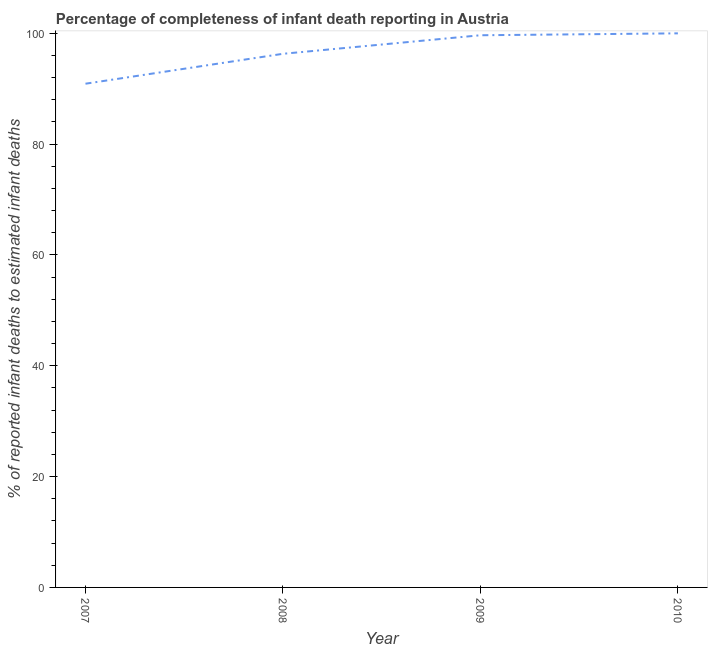What is the completeness of infant death reporting in 2008?
Make the answer very short. 96.31. Across all years, what is the maximum completeness of infant death reporting?
Give a very brief answer. 100. Across all years, what is the minimum completeness of infant death reporting?
Provide a succinct answer. 90.91. In which year was the completeness of infant death reporting maximum?
Your answer should be compact. 2010. What is the sum of the completeness of infant death reporting?
Provide a short and direct response. 386.87. What is the difference between the completeness of infant death reporting in 2008 and 2009?
Keep it short and to the point. -3.35. What is the average completeness of infant death reporting per year?
Your response must be concise. 96.72. What is the median completeness of infant death reporting?
Give a very brief answer. 97.98. In how many years, is the completeness of infant death reporting greater than 88 %?
Offer a terse response. 4. Do a majority of the years between 2010 and 2007 (inclusive) have completeness of infant death reporting greater than 20 %?
Keep it short and to the point. Yes. What is the ratio of the completeness of infant death reporting in 2007 to that in 2010?
Provide a succinct answer. 0.91. Is the completeness of infant death reporting in 2007 less than that in 2009?
Provide a short and direct response. Yes. What is the difference between the highest and the second highest completeness of infant death reporting?
Your answer should be very brief. 0.34. Is the sum of the completeness of infant death reporting in 2009 and 2010 greater than the maximum completeness of infant death reporting across all years?
Make the answer very short. Yes. What is the difference between the highest and the lowest completeness of infant death reporting?
Give a very brief answer. 9.09. In how many years, is the completeness of infant death reporting greater than the average completeness of infant death reporting taken over all years?
Your answer should be very brief. 2. How many lines are there?
Offer a very short reply. 1. Are the values on the major ticks of Y-axis written in scientific E-notation?
Offer a terse response. No. Does the graph contain grids?
Ensure brevity in your answer.  No. What is the title of the graph?
Offer a terse response. Percentage of completeness of infant death reporting in Austria. What is the label or title of the Y-axis?
Ensure brevity in your answer.  % of reported infant deaths to estimated infant deaths. What is the % of reported infant deaths to estimated infant deaths of 2007?
Offer a terse response. 90.91. What is the % of reported infant deaths to estimated infant deaths in 2008?
Offer a terse response. 96.31. What is the % of reported infant deaths to estimated infant deaths in 2009?
Give a very brief answer. 99.66. What is the % of reported infant deaths to estimated infant deaths of 2010?
Your answer should be very brief. 100. What is the difference between the % of reported infant deaths to estimated infant deaths in 2007 and 2008?
Your answer should be compact. -5.4. What is the difference between the % of reported infant deaths to estimated infant deaths in 2007 and 2009?
Offer a terse response. -8.75. What is the difference between the % of reported infant deaths to estimated infant deaths in 2007 and 2010?
Ensure brevity in your answer.  -9.09. What is the difference between the % of reported infant deaths to estimated infant deaths in 2008 and 2009?
Provide a succinct answer. -3.35. What is the difference between the % of reported infant deaths to estimated infant deaths in 2008 and 2010?
Your response must be concise. -3.69. What is the difference between the % of reported infant deaths to estimated infant deaths in 2009 and 2010?
Ensure brevity in your answer.  -0.34. What is the ratio of the % of reported infant deaths to estimated infant deaths in 2007 to that in 2008?
Your answer should be very brief. 0.94. What is the ratio of the % of reported infant deaths to estimated infant deaths in 2007 to that in 2009?
Your answer should be very brief. 0.91. What is the ratio of the % of reported infant deaths to estimated infant deaths in 2007 to that in 2010?
Provide a short and direct response. 0.91. What is the ratio of the % of reported infant deaths to estimated infant deaths in 2009 to that in 2010?
Your response must be concise. 1. 